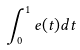<formula> <loc_0><loc_0><loc_500><loc_500>\int _ { 0 } ^ { 1 } e ( t ) d t</formula> 